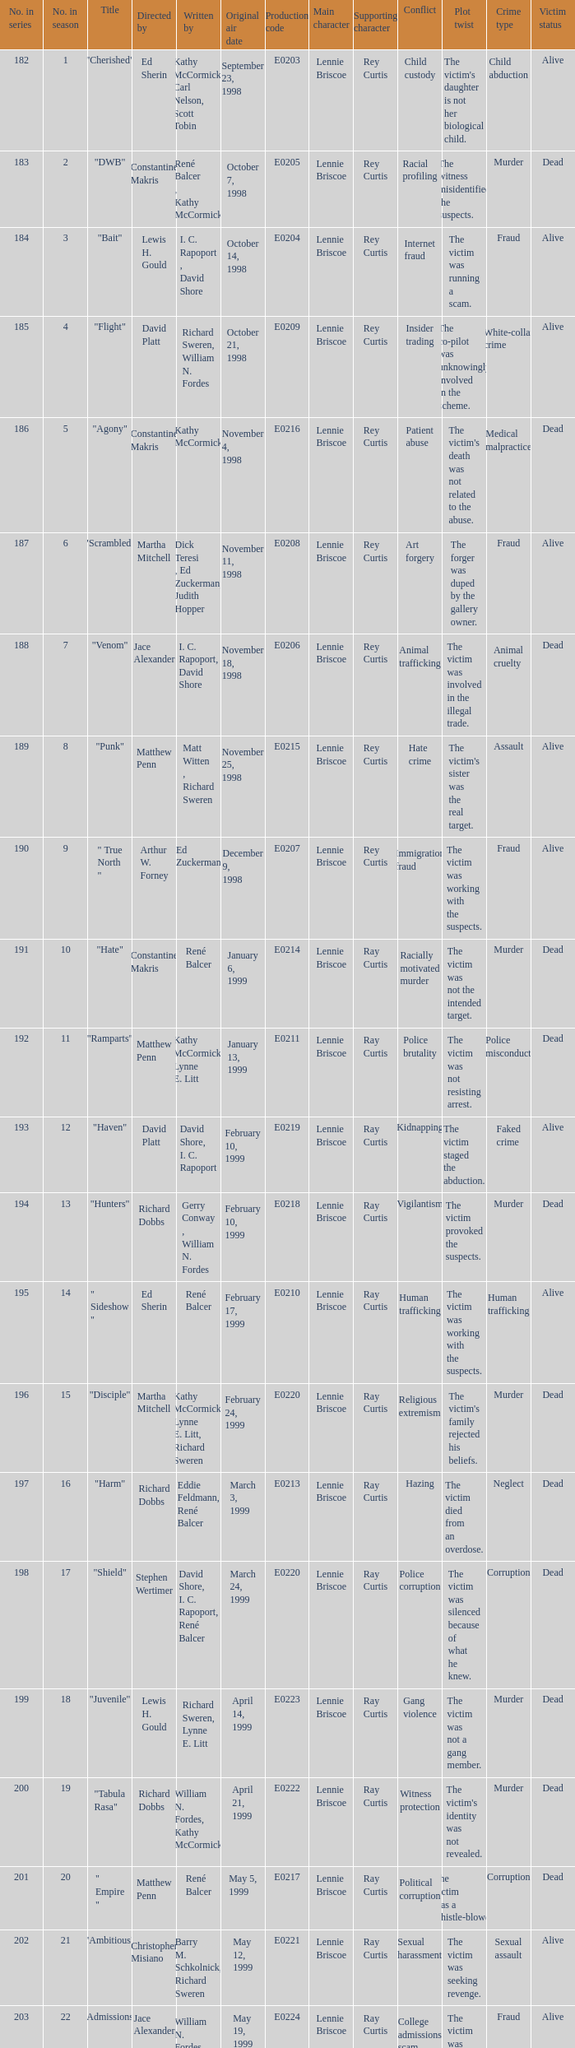What is the title of the episode with the original air date October 21, 1998? "Flight". 